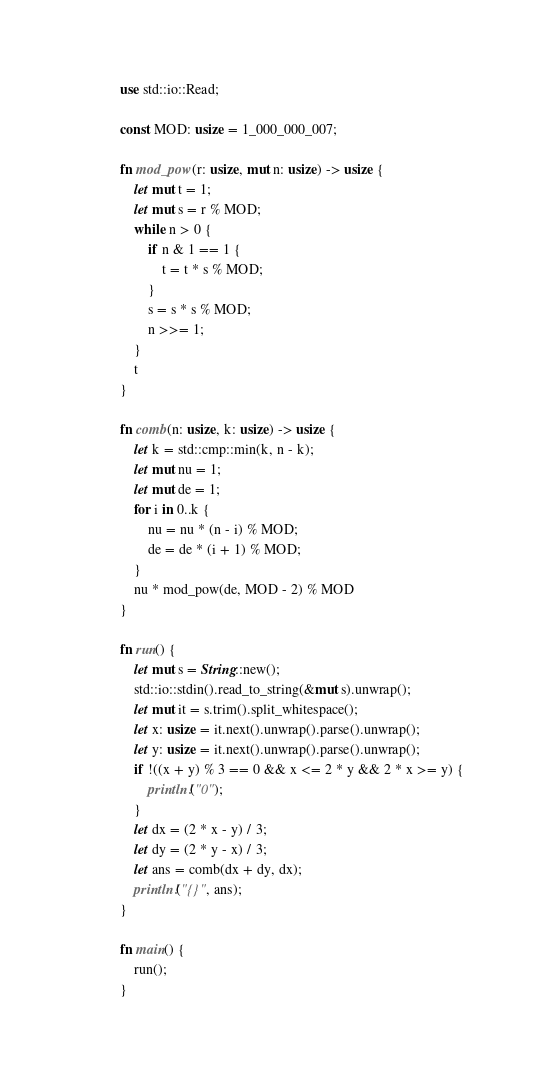<code> <loc_0><loc_0><loc_500><loc_500><_Rust_>use std::io::Read;

const MOD: usize = 1_000_000_007;

fn mod_pow(r: usize, mut n: usize) -> usize {
    let mut t = 1;
    let mut s = r % MOD;
    while n > 0 {
        if n & 1 == 1 {
            t = t * s % MOD;
        }
        s = s * s % MOD;
        n >>= 1;
    }
    t
}

fn comb(n: usize, k: usize) -> usize {
    let k = std::cmp::min(k, n - k);
    let mut nu = 1;
    let mut de = 1;
    for i in 0..k {
        nu = nu * (n - i) % MOD;
        de = de * (i + 1) % MOD;
    }
    nu * mod_pow(de, MOD - 2) % MOD
}

fn run() {
    let mut s = String::new();
    std::io::stdin().read_to_string(&mut s).unwrap();
    let mut it = s.trim().split_whitespace();
    let x: usize = it.next().unwrap().parse().unwrap();
    let y: usize = it.next().unwrap().parse().unwrap();
    if !((x + y) % 3 == 0 && x <= 2 * y && 2 * x >= y) {
        println!("0");
    }
    let dx = (2 * x - y) / 3;
    let dy = (2 * y - x) / 3;
    let ans = comb(dx + dy, dx);
    println!("{}", ans);
}

fn main() {
    run();
}
</code> 